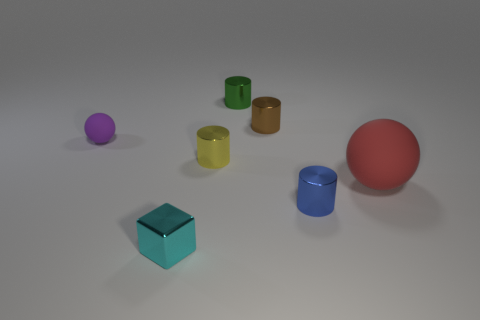Add 1 large spheres. How many objects exist? 8 Subtract all cylinders. How many objects are left? 3 Subtract 0 gray balls. How many objects are left? 7 Subtract all tiny purple spheres. Subtract all tiny yellow metallic things. How many objects are left? 5 Add 2 brown objects. How many brown objects are left? 3 Add 3 tiny metal things. How many tiny metal things exist? 8 